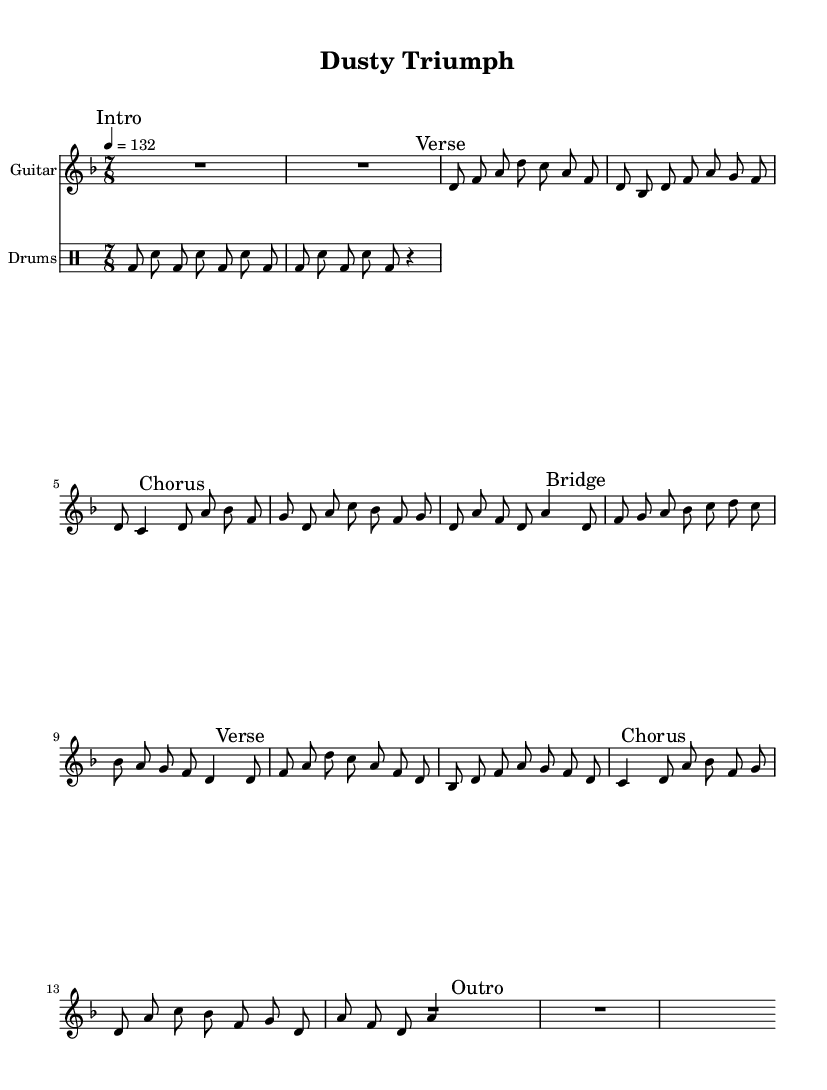What is the key signature of this music? The key signature is identified by the "#" or "b" symbols at the beginning of the staff. In this case, the absence of flats or sharps indicates D minor.
Answer: D minor What is the time signature of this music? The time signature is noted at the beginning of the staff, shown as a fraction. Here, it is represented as 7/8, meaning there are seven eighth notes in each measure.
Answer: 7/8 What is the tempo marking of this composition? The tempo marking indicates how fast the music should be played. In the sheet music, it states "4 = 132," meaning there should be 132 beats per minute.
Answer: 132 How many measures are in the "Chorus" section? To find the number of measures, we count the number of bars (vertical lines) in the "Chorus" section marked in the sheet music. There are two measures in this section.
Answer: 2 What is the primary theme of the "Bridge"? The "Bridge" section contains the main theme, which is indicated by the "mainTheme" marking. It consists of a specific sequence of notes that centers the composition around the theme of perseverance.
Answer: Dusty Triumph What instruments are featured in this sheet music? The instruments are specified at the beginning of each staff in the score. The score shows a "Guitar" staff and a "Drums" staff, confirming the use of these two instruments.
Answer: Guitar and Drums What rhythmic pattern is used in the Drums section? The rhythmic pattern for the drums is described using note values (bd for bass drum and sn for snare). In this code, a repeating pattern of bass and snare notes is used over several measures.
Answer: Bass and Snare 